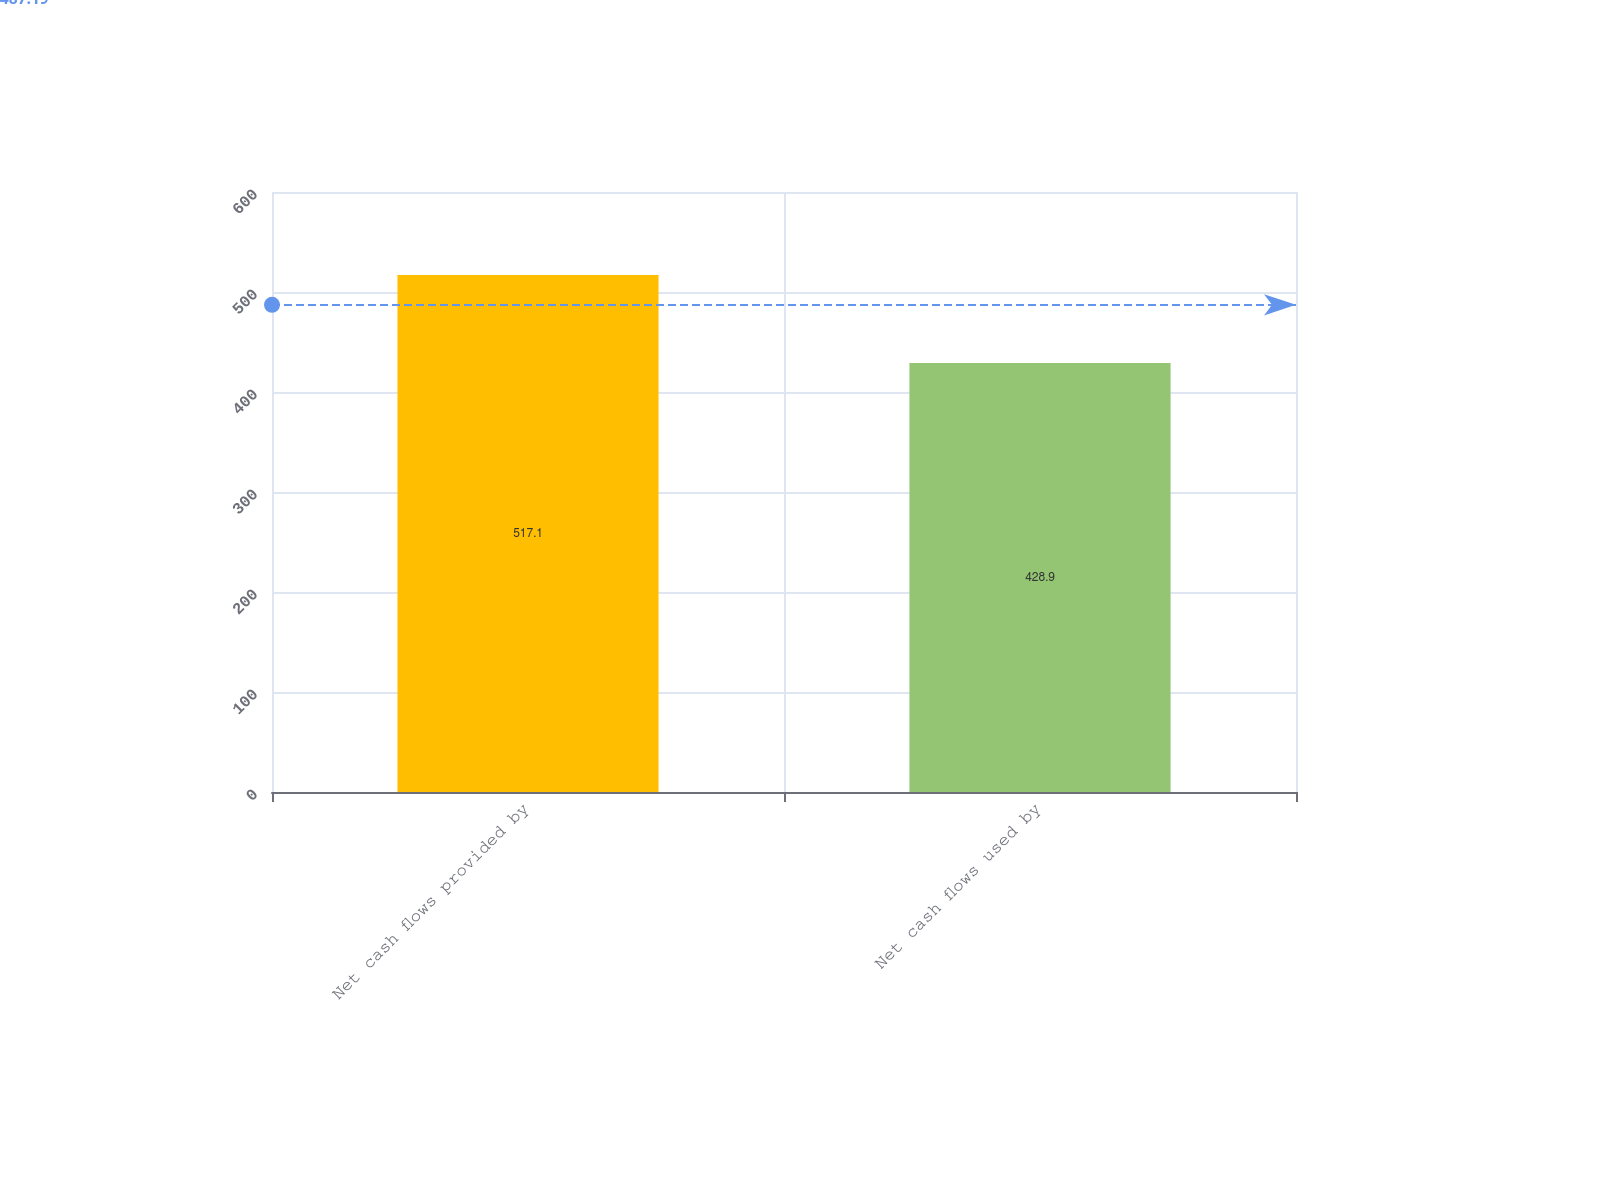<chart> <loc_0><loc_0><loc_500><loc_500><bar_chart><fcel>Net cash flows provided by<fcel>Net cash flows used by<nl><fcel>517.1<fcel>428.9<nl></chart> 